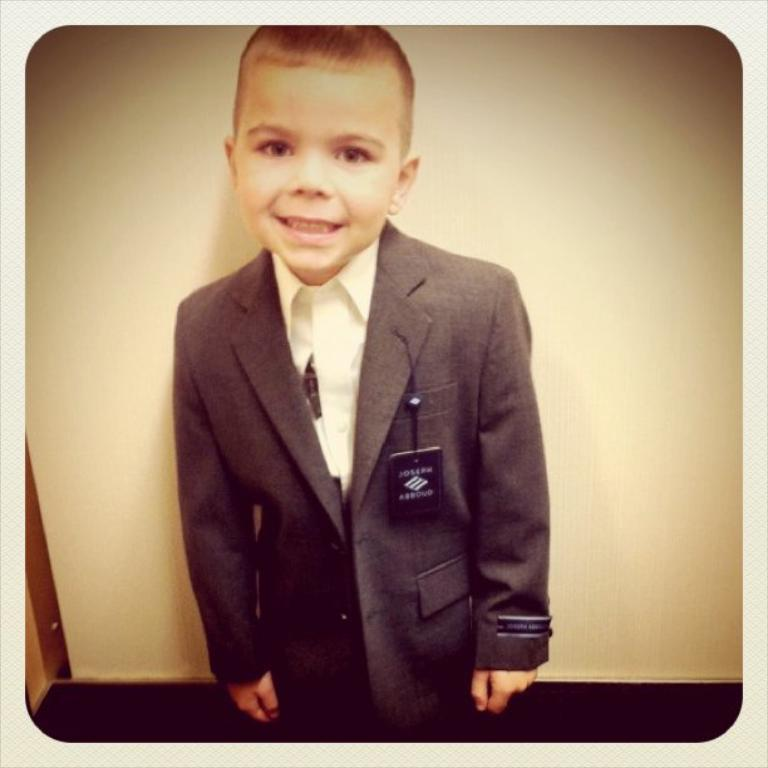Who is the main subject in the picture? There is a boy in the picture. What is the boy wearing? The boy is wearing a suit. What can be seen in the background of the picture? There is a white wall in the background of the picture. What type of frame is around the parcel in the image? There is no parcel or frame present in the image; it features a boy wearing a suit with a white wall in the background. 